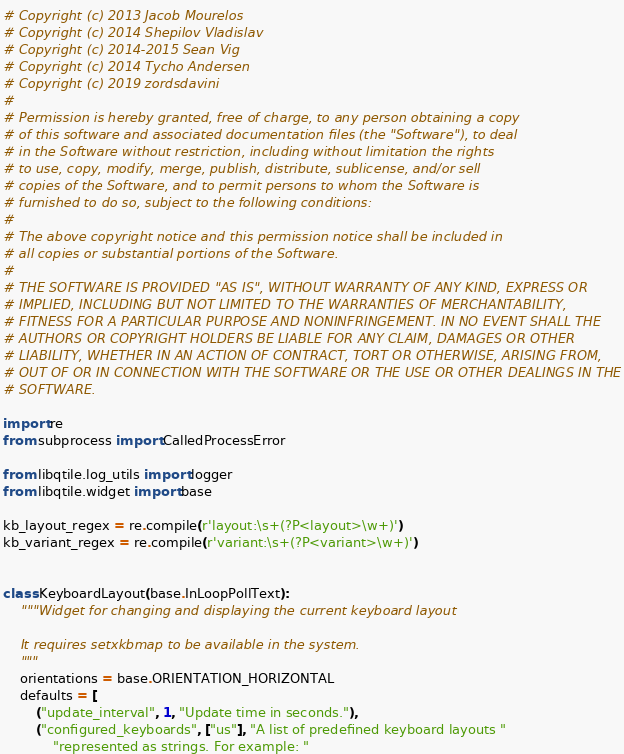Convert code to text. <code><loc_0><loc_0><loc_500><loc_500><_Python_># Copyright (c) 2013 Jacob Mourelos
# Copyright (c) 2014 Shepilov Vladislav
# Copyright (c) 2014-2015 Sean Vig
# Copyright (c) 2014 Tycho Andersen
# Copyright (c) 2019 zordsdavini
#
# Permission is hereby granted, free of charge, to any person obtaining a copy
# of this software and associated documentation files (the "Software"), to deal
# in the Software without restriction, including without limitation the rights
# to use, copy, modify, merge, publish, distribute, sublicense, and/or sell
# copies of the Software, and to permit persons to whom the Software is
# furnished to do so, subject to the following conditions:
#
# The above copyright notice and this permission notice shall be included in
# all copies or substantial portions of the Software.
#
# THE SOFTWARE IS PROVIDED "AS IS", WITHOUT WARRANTY OF ANY KIND, EXPRESS OR
# IMPLIED, INCLUDING BUT NOT LIMITED TO THE WARRANTIES OF MERCHANTABILITY,
# FITNESS FOR A PARTICULAR PURPOSE AND NONINFRINGEMENT. IN NO EVENT SHALL THE
# AUTHORS OR COPYRIGHT HOLDERS BE LIABLE FOR ANY CLAIM, DAMAGES OR OTHER
# LIABILITY, WHETHER IN AN ACTION OF CONTRACT, TORT OR OTHERWISE, ARISING FROM,
# OUT OF OR IN CONNECTION WITH THE SOFTWARE OR THE USE OR OTHER DEALINGS IN THE
# SOFTWARE.

import re
from subprocess import CalledProcessError

from libqtile.log_utils import logger
from libqtile.widget import base

kb_layout_regex = re.compile(r'layout:\s+(?P<layout>\w+)')
kb_variant_regex = re.compile(r'variant:\s+(?P<variant>\w+)')


class KeyboardLayout(base.InLoopPollText):
    """Widget for changing and displaying the current keyboard layout

    It requires setxkbmap to be available in the system.
    """
    orientations = base.ORIENTATION_HORIZONTAL
    defaults = [
        ("update_interval", 1, "Update time in seconds."),
        ("configured_keyboards", ["us"], "A list of predefined keyboard layouts "
            "represented as strings. For example: "</code> 